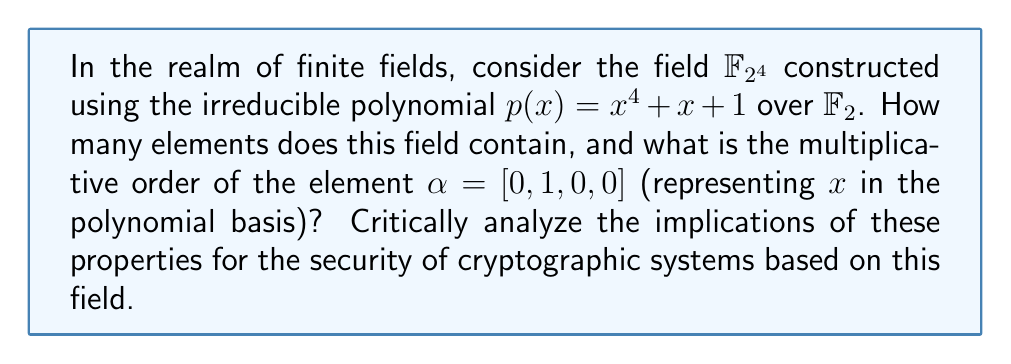Provide a solution to this math problem. Let's approach this step-by-step:

1) Number of elements:
   - A finite field $\mathbb{F}_{p^n}$ has $p^n$ elements, where $p$ is prime and $n$ is a positive integer.
   - Here, $p = 2$ and $n = 4$, so $|\mathbb{F}_{2^4}| = 2^4 = 16$ elements.

2) Multiplicative order of $\alpha$:
   - First, let's compute powers of $\alpha$:
     $\alpha^1 = [0, 1, 0, 0]$
     $\alpha^2 = [0, 0, 1, 0]$
     $\alpha^3 = [0, 0, 0, 1]$
     $\alpha^4 = [1, 1, 0, 0]$ (using $x^4 = x + 1$ from $p(x)$)
     $\alpha^5 = [1, 1, 1, 0]$
     ...
     $\alpha^{15} = [1, 0, 0, 0]$
     $\alpha^{16} = [0, 1, 0, 0] = \alpha^1$

   - The multiplicative order is the smallest positive integer $k$ such that $\alpha^k = 1$.
   - We see that $\alpha^{15} = [1, 0, 0, 0]$, which is the multiplicative identity.
   - Therefore, the multiplicative order of $\alpha$ is 15.

3) Implications for cryptography:
   - The field size (16) determines the key space. A small field like this is not secure for real-world cryptography.
   - The multiplicative order of $\alpha$ being 15 (primitive element) means it generates all non-zero elements of the field.
   - This property is crucial for certain cryptographic algorithms, like the generation of pseudo-random sequences.
   - However, the small size of this field makes it vulnerable to exhaustive search attacks.
   - In practice, much larger fields (e.g., $\mathbb{F}_{2^{256}}$) are used to ensure adequate security.

4) Critical analysis:
   - While this field demonstrates important algebraic properties used in cryptography, its small size renders it impractical for real-world applications.
   - The ease of computing all field elements and their properties in this case highlights the importance of choosing appropriately large fields in cryptographic systems.
   - The existence of a primitive element (generator) is beneficial for cryptographic constructions, but the security relies on the computational infeasibility of certain operations in much larger fields.
Answer: 16 elements; multiplicative order of $\alpha$ is 15 